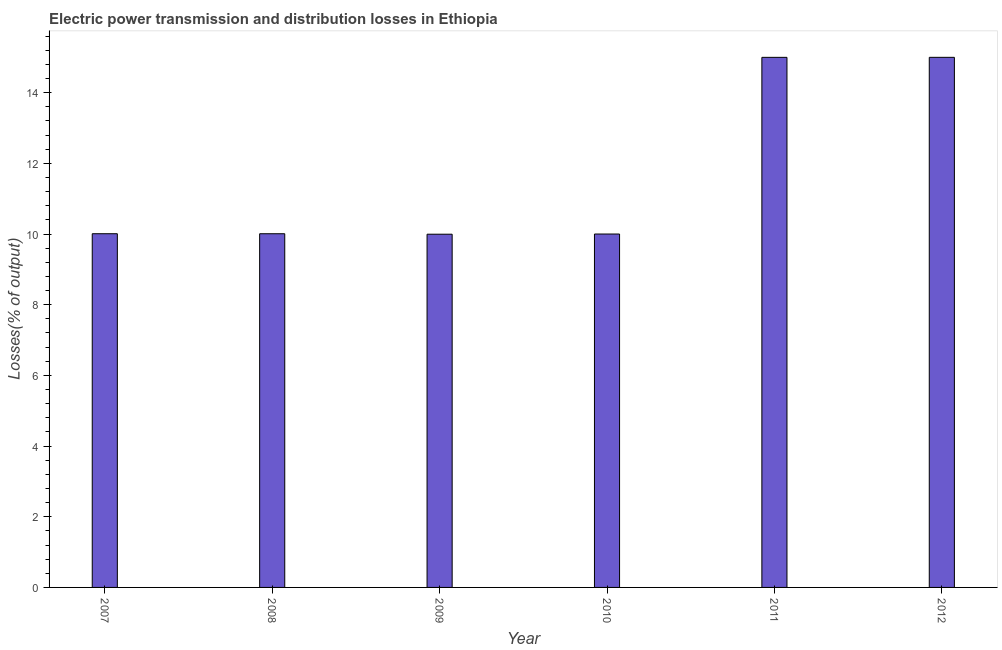What is the title of the graph?
Offer a very short reply. Electric power transmission and distribution losses in Ethiopia. What is the label or title of the Y-axis?
Provide a short and direct response. Losses(% of output). Across all years, what is the maximum electric power transmission and distribution losses?
Ensure brevity in your answer.  15. Across all years, what is the minimum electric power transmission and distribution losses?
Provide a short and direct response. 9.99. In which year was the electric power transmission and distribution losses maximum?
Your response must be concise. 2012. What is the sum of the electric power transmission and distribution losses?
Offer a terse response. 70.01. What is the difference between the electric power transmission and distribution losses in 2008 and 2010?
Your answer should be very brief. 0.01. What is the average electric power transmission and distribution losses per year?
Your answer should be compact. 11.67. What is the median electric power transmission and distribution losses?
Provide a short and direct response. 10.01. What is the ratio of the electric power transmission and distribution losses in 2007 to that in 2012?
Give a very brief answer. 0.67. Is the difference between the electric power transmission and distribution losses in 2008 and 2009 greater than the difference between any two years?
Your answer should be very brief. No. Is the sum of the electric power transmission and distribution losses in 2007 and 2008 greater than the maximum electric power transmission and distribution losses across all years?
Your answer should be very brief. Yes. What is the difference between the highest and the lowest electric power transmission and distribution losses?
Ensure brevity in your answer.  5.01. How many bars are there?
Make the answer very short. 6. Are all the bars in the graph horizontal?
Make the answer very short. No. What is the difference between two consecutive major ticks on the Y-axis?
Offer a terse response. 2. Are the values on the major ticks of Y-axis written in scientific E-notation?
Offer a terse response. No. What is the Losses(% of output) in 2007?
Keep it short and to the point. 10.01. What is the Losses(% of output) of 2008?
Your answer should be compact. 10.01. What is the Losses(% of output) in 2009?
Provide a succinct answer. 9.99. What is the Losses(% of output) of 2011?
Your answer should be very brief. 15. What is the Losses(% of output) of 2012?
Give a very brief answer. 15. What is the difference between the Losses(% of output) in 2007 and 2008?
Keep it short and to the point. 0. What is the difference between the Losses(% of output) in 2007 and 2009?
Offer a very short reply. 0.01. What is the difference between the Losses(% of output) in 2007 and 2010?
Keep it short and to the point. 0.01. What is the difference between the Losses(% of output) in 2007 and 2011?
Make the answer very short. -4.99. What is the difference between the Losses(% of output) in 2007 and 2012?
Offer a very short reply. -4.99. What is the difference between the Losses(% of output) in 2008 and 2009?
Your answer should be compact. 0.01. What is the difference between the Losses(% of output) in 2008 and 2010?
Offer a terse response. 0.01. What is the difference between the Losses(% of output) in 2008 and 2011?
Offer a terse response. -4.99. What is the difference between the Losses(% of output) in 2008 and 2012?
Your answer should be very brief. -4.99. What is the difference between the Losses(% of output) in 2009 and 2010?
Provide a short and direct response. -0.01. What is the difference between the Losses(% of output) in 2009 and 2011?
Your answer should be very brief. -5. What is the difference between the Losses(% of output) in 2009 and 2012?
Make the answer very short. -5.01. What is the difference between the Losses(% of output) in 2010 and 2011?
Make the answer very short. -5. What is the difference between the Losses(% of output) in 2010 and 2012?
Make the answer very short. -5. What is the difference between the Losses(% of output) in 2011 and 2012?
Offer a very short reply. -0. What is the ratio of the Losses(% of output) in 2007 to that in 2008?
Provide a succinct answer. 1. What is the ratio of the Losses(% of output) in 2007 to that in 2009?
Give a very brief answer. 1. What is the ratio of the Losses(% of output) in 2007 to that in 2010?
Keep it short and to the point. 1. What is the ratio of the Losses(% of output) in 2007 to that in 2011?
Give a very brief answer. 0.67. What is the ratio of the Losses(% of output) in 2007 to that in 2012?
Give a very brief answer. 0.67. What is the ratio of the Losses(% of output) in 2008 to that in 2011?
Provide a succinct answer. 0.67. What is the ratio of the Losses(% of output) in 2008 to that in 2012?
Offer a terse response. 0.67. What is the ratio of the Losses(% of output) in 2009 to that in 2011?
Ensure brevity in your answer.  0.67. What is the ratio of the Losses(% of output) in 2009 to that in 2012?
Make the answer very short. 0.67. What is the ratio of the Losses(% of output) in 2010 to that in 2011?
Offer a very short reply. 0.67. What is the ratio of the Losses(% of output) in 2010 to that in 2012?
Offer a terse response. 0.67. What is the ratio of the Losses(% of output) in 2011 to that in 2012?
Ensure brevity in your answer.  1. 